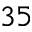Convert formula to latex. <formula><loc_0><loc_0><loc_500><loc_500>^ { 3 5 }</formula> 